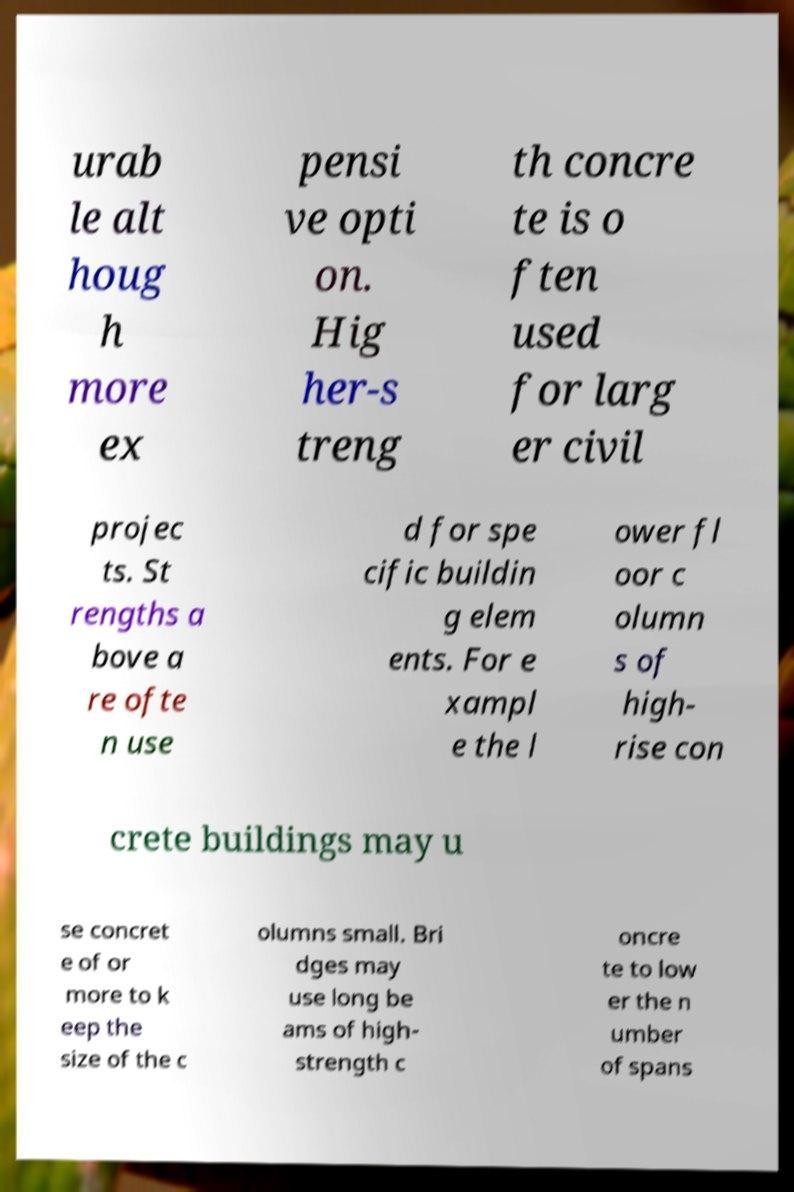Could you extract and type out the text from this image? urab le alt houg h more ex pensi ve opti on. Hig her-s treng th concre te is o ften used for larg er civil projec ts. St rengths a bove a re ofte n use d for spe cific buildin g elem ents. For e xampl e the l ower fl oor c olumn s of high- rise con crete buildings may u se concret e of or more to k eep the size of the c olumns small. Bri dges may use long be ams of high- strength c oncre te to low er the n umber of spans 